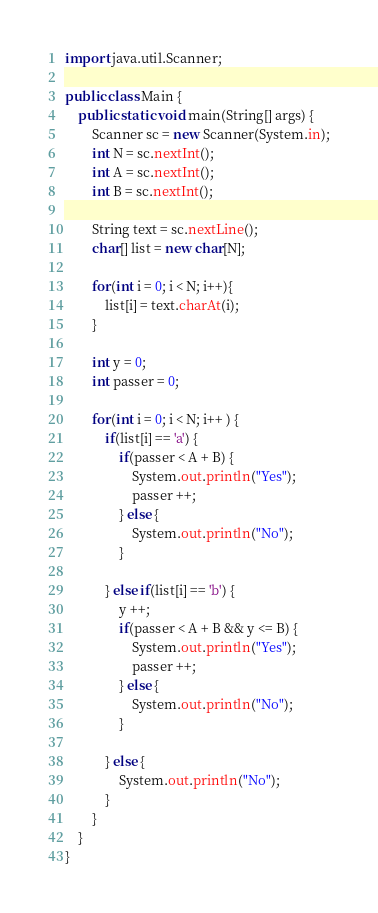<code> <loc_0><loc_0><loc_500><loc_500><_Java_>import java.util.Scanner;

public class Main {
	public static void main(String[] args) {
		Scanner sc = new Scanner(System.in);
		int N = sc.nextInt();
		int A = sc.nextInt();
		int B = sc.nextInt();

		String text = sc.nextLine();
		char[] list = new char[N];

		for(int i = 0; i < N; i++){
			list[i] = text.charAt(i);
		}

		int y = 0;
		int passer = 0;

		for(int i = 0; i < N; i++ ) {
			if(list[i] == 'a') {
				if(passer < A + B) {
					System.out.println("Yes");
					passer ++;
				} else {
					System.out.println("No");
				}

			} else if(list[i] == 'b') {
				y ++;
				if(passer < A + B && y <= B) {
					System.out.println("Yes");
					passer ++;
				} else {
					System.out.println("No");
				}

			} else {
				System.out.println("No");
			}
		}
	}
}
</code> 